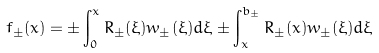<formula> <loc_0><loc_0><loc_500><loc_500>f _ { \pm } ( x ) = \pm \int _ { 0 } ^ { x } R _ { \pm } ( \xi ) w _ { \pm } ( \xi ) d \xi \pm \int _ { x } ^ { b _ { \pm } } R _ { \pm } ( x ) w _ { \pm } ( \xi ) d \xi</formula> 